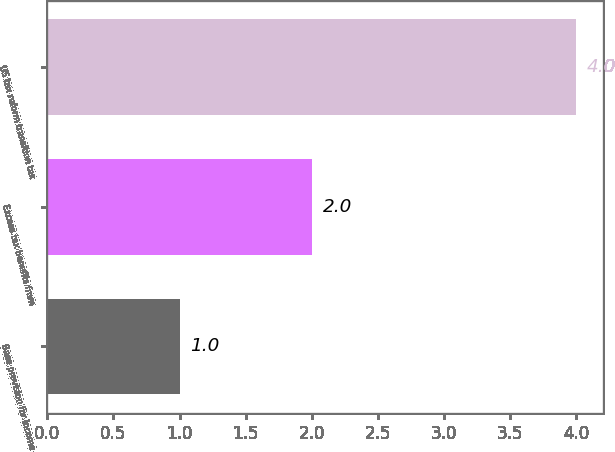<chart> <loc_0><loc_0><loc_500><loc_500><bar_chart><fcel>Base provision for income<fcel>Excess tax benefits from<fcel>US tax reform transition tax<nl><fcel>1<fcel>2<fcel>4<nl></chart> 